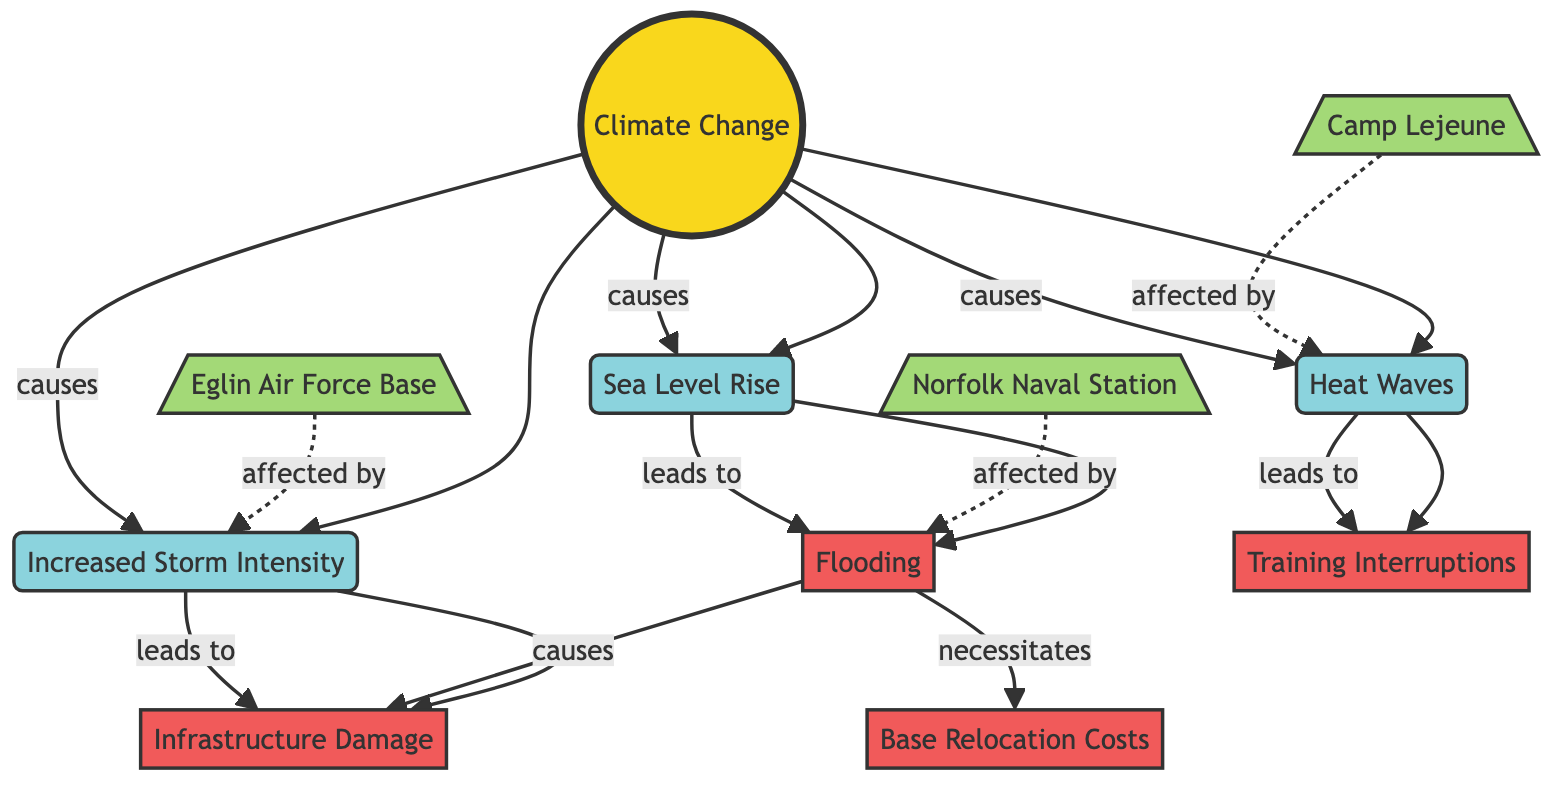What are the three main impacts of climate change listed in the diagram? The diagram shows three main impacts caused by climate change: Sea Level Rise, Increased Storm Intensity, and Heat Waves. These are the child nodes directly linked to the Climate Change root node.
Answer: Sea Level Rise, Increased Storm Intensity, Heat Waves Which military base is affected by flooding? The diagram states that Norfolk Naval Station is affected by flooding as indicated by the dashed line connecting the military base node to the flooding result node.
Answer: Norfolk Naval Station What leads to infrastructure damage according to the diagram? The diagram indicates that increased storm intensity leads to infrastructure damage. This can be followed by the edge from Increased Storm Intensity to Infrastructure Damage node.
Answer: Increased Storm Intensity How many military bases are mentioned in the diagram? There are three military bases mentioned in the diagram: Norfolk Naval Station, Eglin Air Force Base, and Camp Lejeune. The count can be obtained directly from the military base nodes listed.
Answer: 3 What impact necessitates base relocation costs? The diagram specifies that flooding necessitates base relocation costs. This relationship is indicated by the directed edge from Flooding to Base Relocation Costs.
Answer: Flooding Which environmental factor leads to training interruptions? According to the diagram, heat waves lead to training interruptions. This relationship is evident from the directed edge connecting Heat Waves to Training Interruptions.
Answer: Heat Waves What are the two results that are caused by flooding? Flooding causes two results according to the diagram: Infrastructure Damage and Base Relocation Costs. This can be verified from the edges stemming from the Flooding node.
Answer: Infrastructure Damage, Base Relocation Costs How many edges lead from climate change to its impacts? The diagram shows three edges leading from the Climate Change node to its impacts: one for each of Sea Level Rise, Increased Storm Intensity, and Heat Waves. This can be counted from the connections stemming from the root node.
Answer: 3 